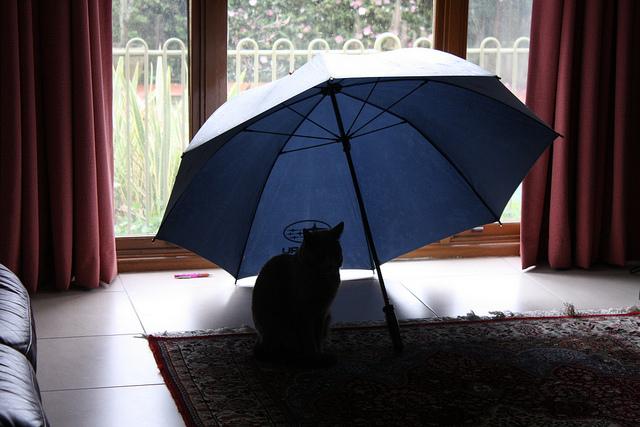Is the animal alive?
Be succinct. Yes. Is it raining?
Concise answer only. No. What is the cat under?
Answer briefly. Umbrella. 